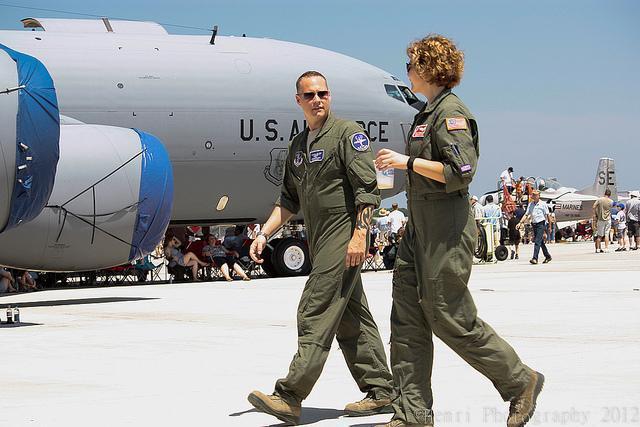How many airplanes are visible?
Give a very brief answer. 2. How many people are there?
Give a very brief answer. 3. 